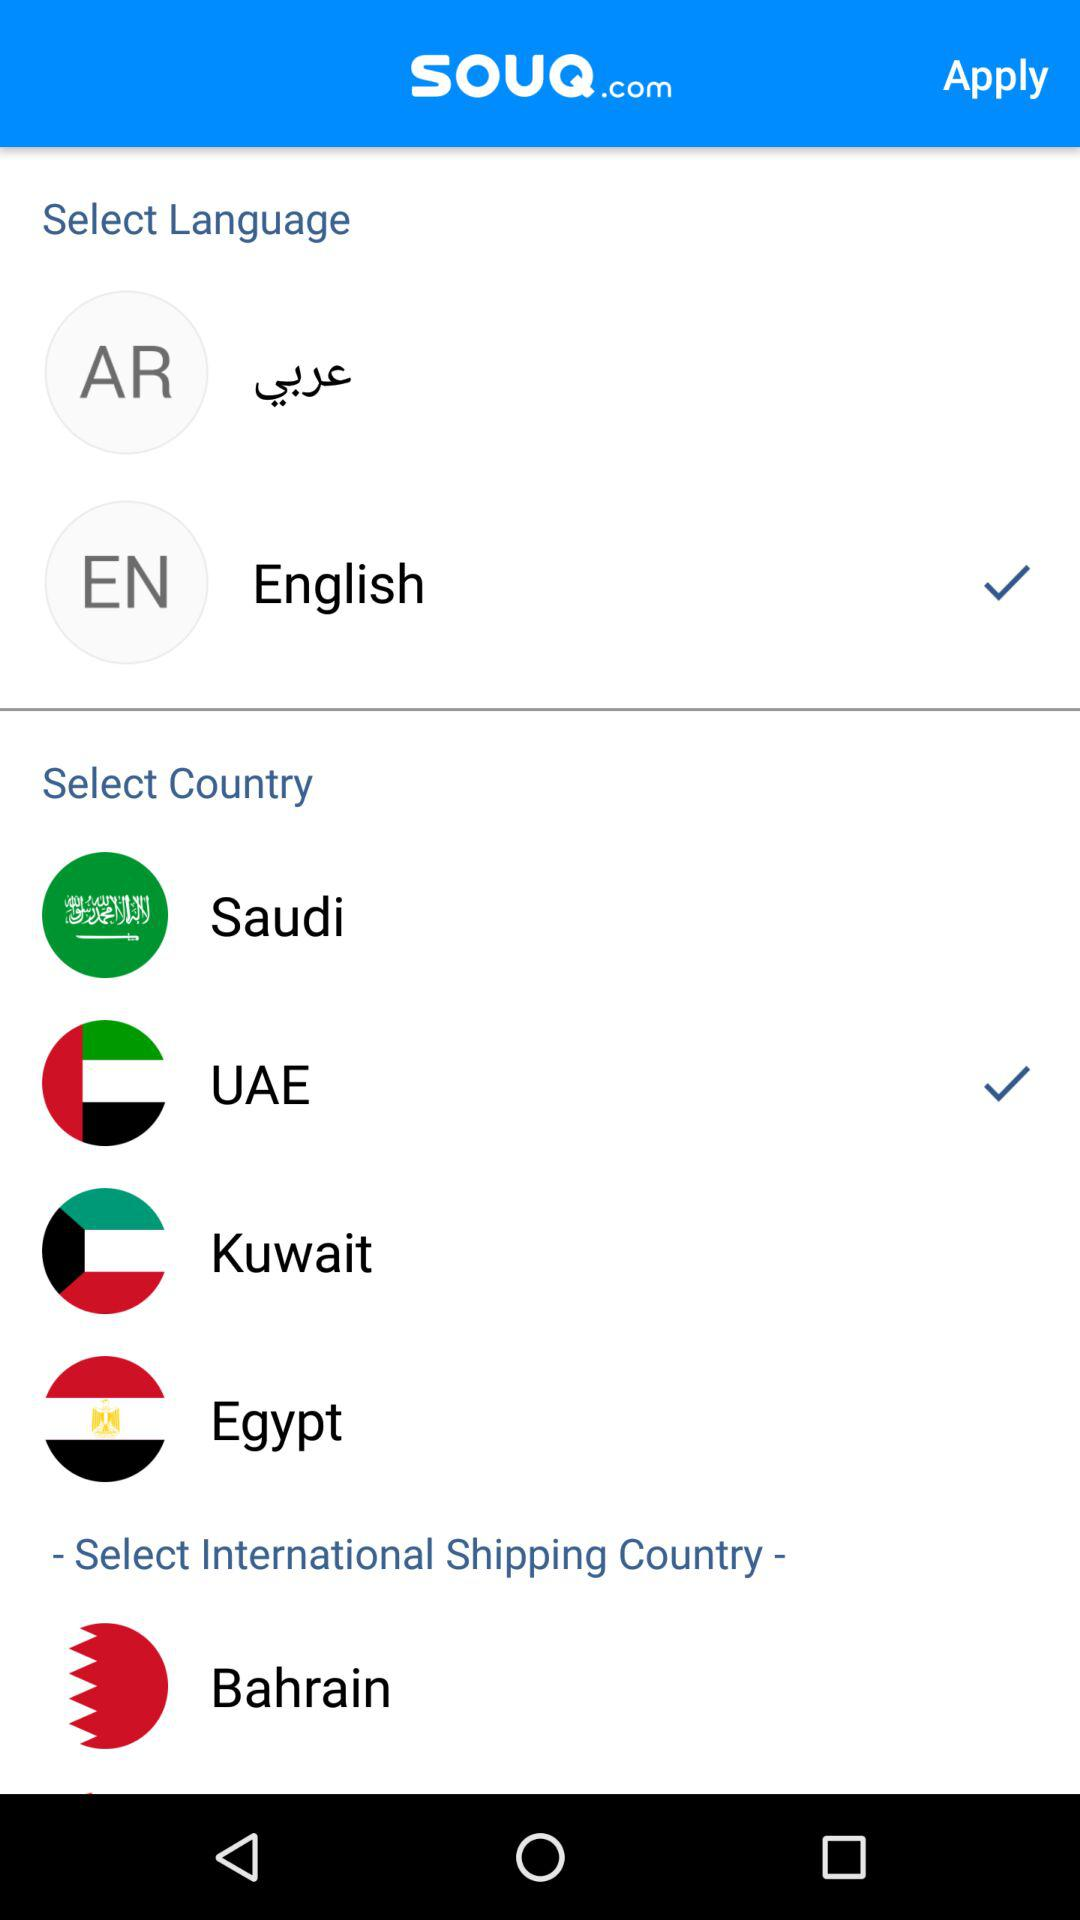What is the name of the application? The name of the application is "SOUQ.com". 